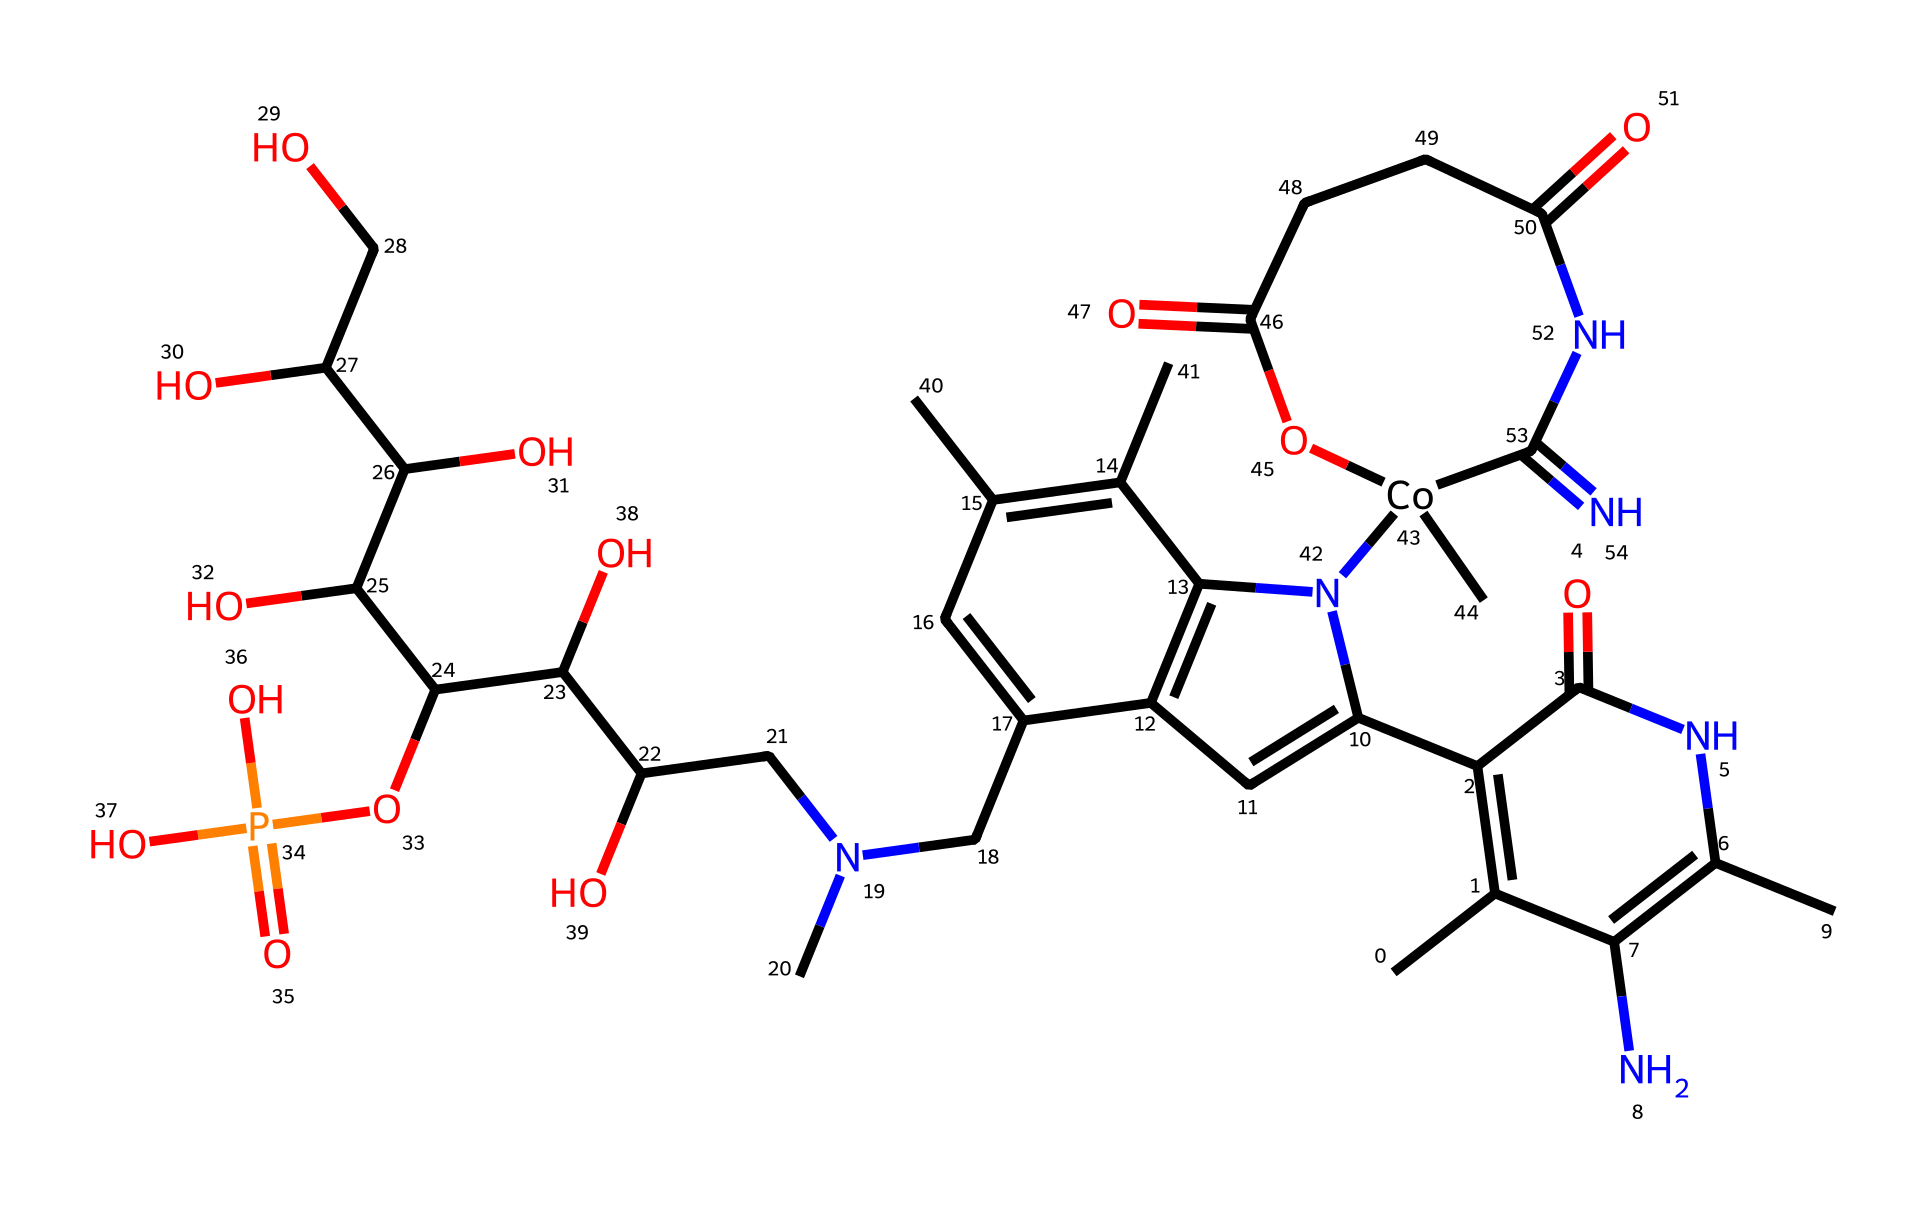What is the molecular formula of Vitamin B12? To determine the molecular formula, we look for the counts of each type of atom in the SMILES representation. Specifically, we identify the presence of carbon, hydrogen, nitrogen, oxygen, and cobalt atoms. After analyzing the structure, the counts yield C63, H88, N14, O14, Co.
Answer: C63H88N14O14Co How many rings are present in the structure of Vitamin B12? By examining the structure in the SMILES, we can identify the interconnected ring systems. Upon close inspection, the structure contains multiple fused and separate ring elements, which can be counted. Ultimately, there are four distinct rings within the structure.
Answer: 4 What is the role of Vitamin B12 in energy metabolism? Vitamin B12 is known for its crucial role in the metabolism of cells, particularly in the conversion of certain biomolecules into usable energy forms. This role is primarily linked to its function as a coenzyme in the synthesis of fatty acids and amino acids.
Answer: Coenzyme How many nitrogen atoms are present in the chemical structure of Vitamin B12? To find the number of nitrogen atoms, we count the instances of nitrogen (N) in the SMILES notation. Upon analysis, we find that there are 14 nitrogen atoms present in the structure.
Answer: 14 Which specific cofactor does Vitamin B12 include in its structure? The structure of Vitamin B12 includes the cobalt atom, which is central to its function. Cobalt is a metal that is coordinated by the surrounding nitrogen atoms in the structure, making it a distinct feature of the vitamin.
Answer: Cobalt What functional groups are identified in Vitamin B12? The presence of various functional groups can be examined by identifying the specific arrangements within the structure. In the case of Vitamin B12, we identify amine, hydroxyl, and carboxylic acid functional groups among others, which contribute to its biochemical properties.
Answer: Amine, hydroxyl, carboxylic acid 